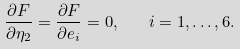<formula> <loc_0><loc_0><loc_500><loc_500>\frac { \partial F } { \partial \eta _ { 2 } } = \frac { \partial F } { \partial e _ { i } } = 0 , \quad i = 1 , \dots , 6 .</formula> 